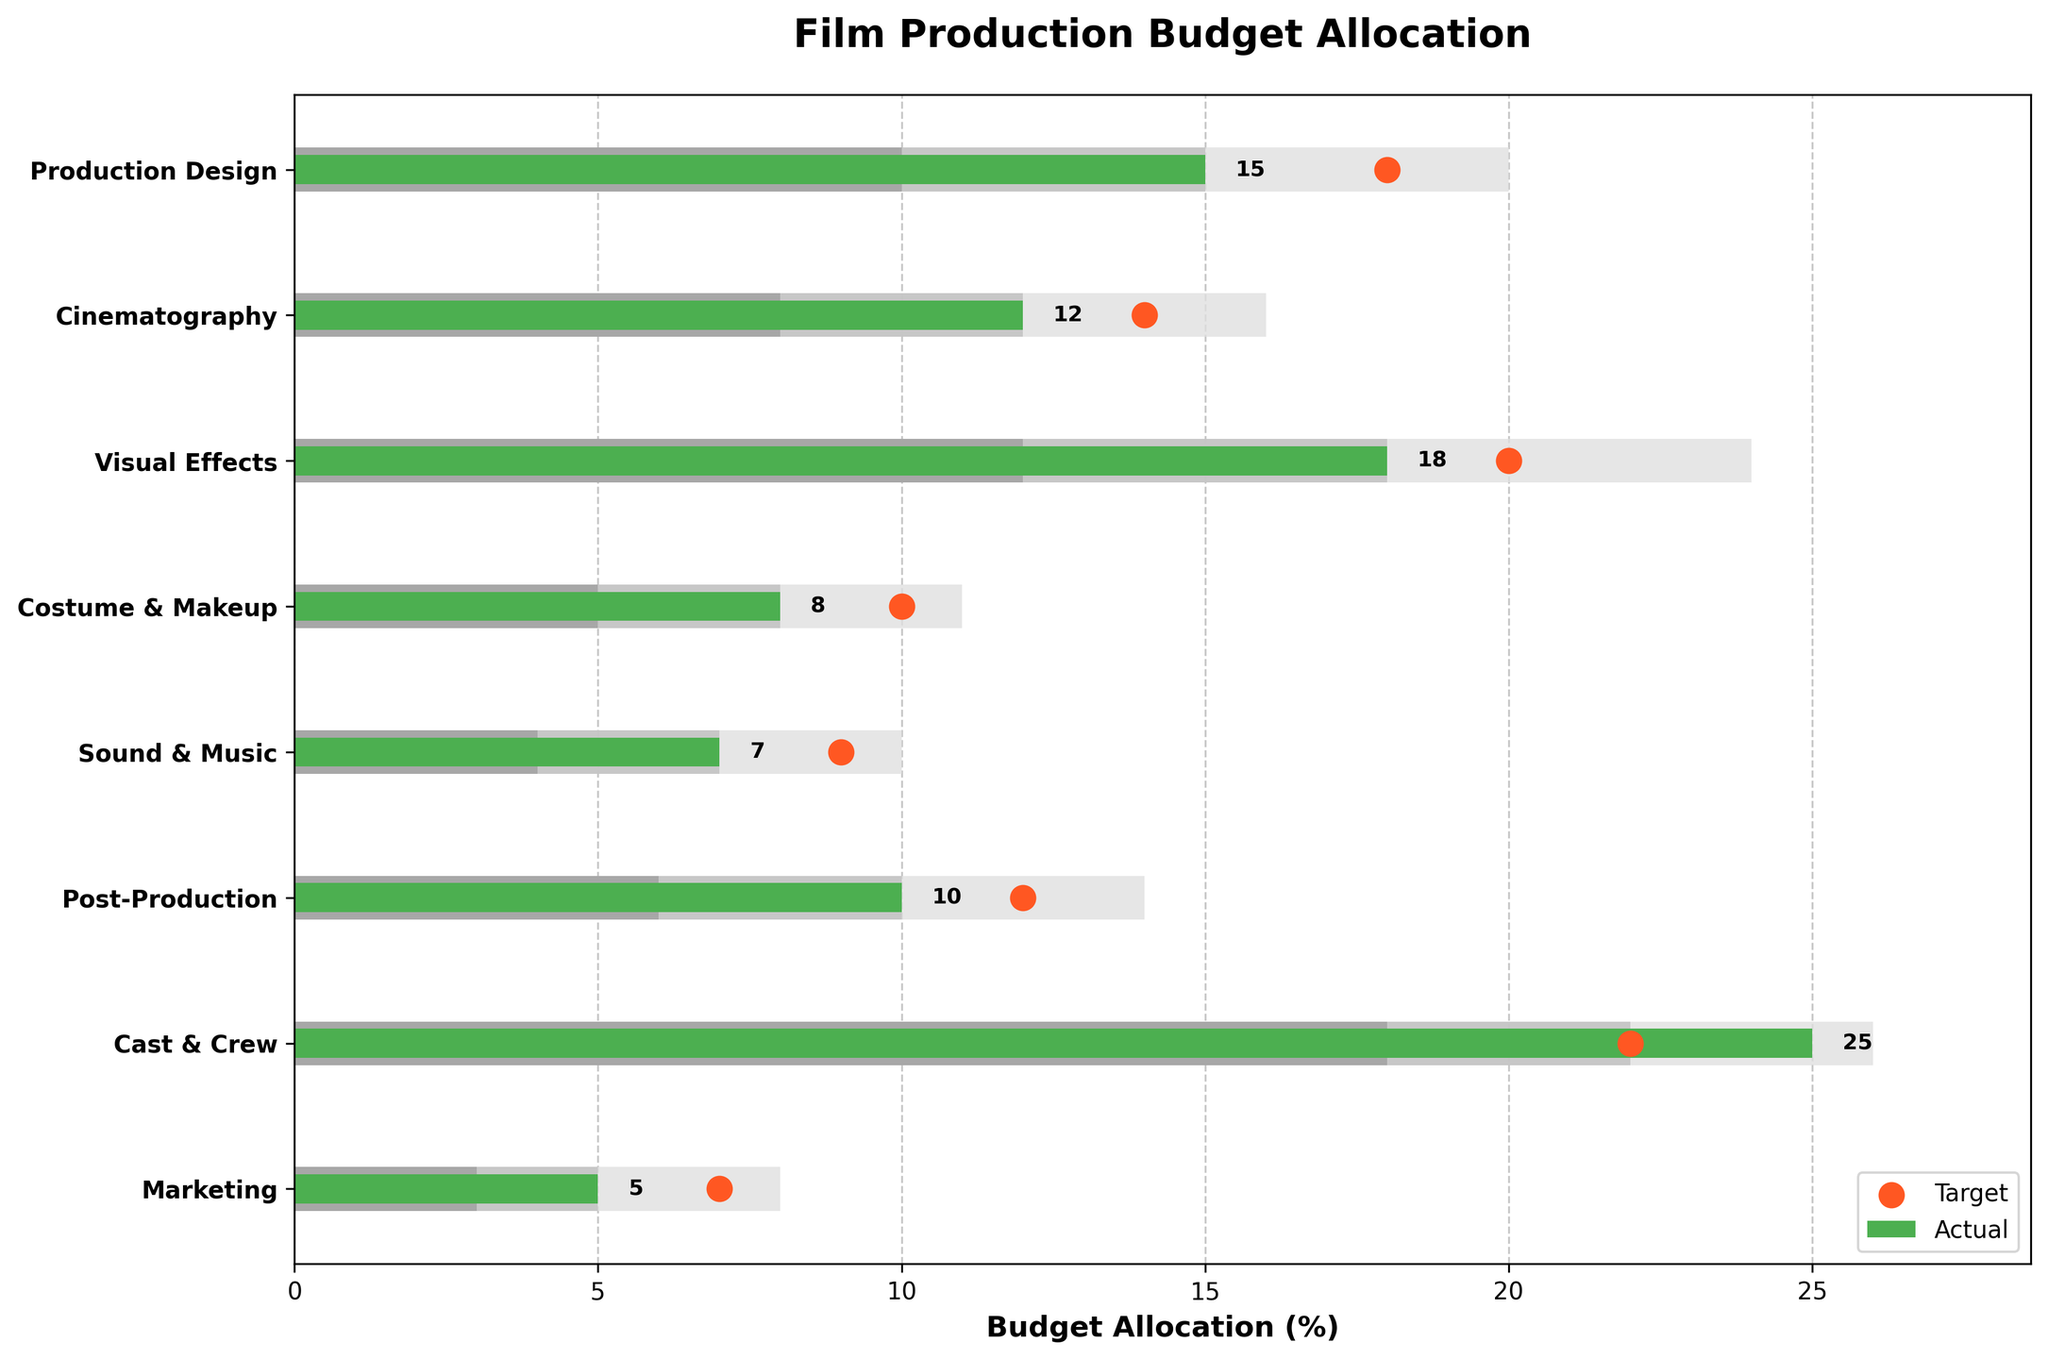What is the title of the chart? The title of the chart is usually displayed prominently at the top of the figure.
Answer: Film Production Budget Allocation Which department has the highest actual budget allocation? Look at the bars representing the 'Actual' values and identify the tallest one. 'Cast & Crew' has the tallest bar.
Answer: Cast & Crew What is the target budget allocation for Visual Effects? Locate the target marker (red dot) for the 'Visual Effects' department. The red dot appears at 20%.
Answer: 20% Which department has the actual budget exceeding the target budget? Compare the 'Actual' bars and the target markers (red dots) for all departments. 'Cast & Crew' has an actual value of 25% which exceeds its target of 22%.
Answer: Cast & Crew How many departments have an actual budget allocation of less than 10%? Identify the height of the 'Actual' bars that are less than 10%. There are four such departments: 'Costume & Makeup', 'Sound & Music', 'Marketing', and 'Cinematography'.
Answer: 4 What is the difference between the actual and target budget allocation for Production Design? Subtract the actual value from the target value for 'Production Design'. The difference is 18% - 15% = 3%.
Answer: 3% Which department's actual budget allocation falls below its first range? Compare the 'Actual' bars with the first range (darkest gray bar). 'Cinematography' has an actual value of 12% which does not fall below its first range of 8%. Therefore, no department's actual allocation falls below its first range.
Answer: None How many departments have actual budgets within the second range? Check the 'Actual' bars that fall within the second range (middle gray bar). 'Cinematography', 'Costume & Makeup', 'Sound & Music', and 'Post-Production' fit this criterion.
Answer: 4 